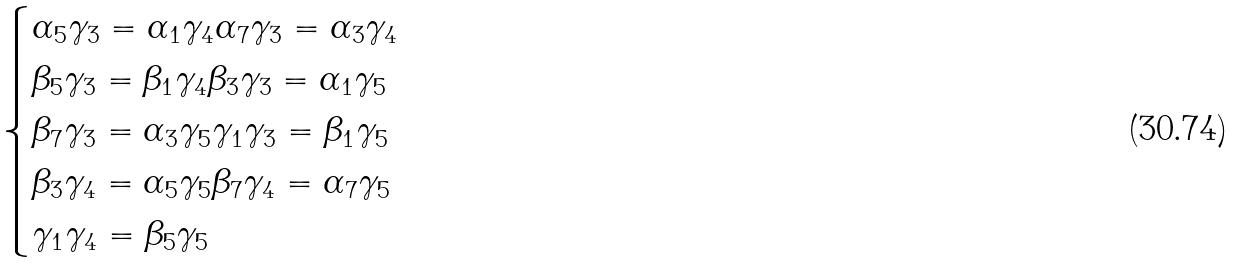Convert formula to latex. <formula><loc_0><loc_0><loc_500><loc_500>\begin{cases} \alpha _ { 5 } \gamma _ { 3 } = \alpha _ { 1 } \gamma _ { 4 } \alpha _ { 7 } \gamma _ { 3 } = \alpha _ { 3 } \gamma _ { 4 } \\ \beta _ { 5 } \gamma _ { 3 } = \beta _ { 1 } \gamma _ { 4 } \beta _ { 3 } \gamma _ { 3 } = \alpha _ { 1 } \gamma _ { 5 } \\ \beta _ { 7 } \gamma _ { 3 } = \alpha _ { 3 } \gamma _ { 5 } \gamma _ { 1 } \gamma _ { 3 } = \beta _ { 1 } \gamma _ { 5 } \\ \beta _ { 3 } \gamma _ { 4 } = \alpha _ { 5 } \gamma _ { 5 } \beta _ { 7 } \gamma _ { 4 } = \alpha _ { 7 } \gamma _ { 5 } \\ \gamma _ { 1 } \gamma _ { 4 } = \beta _ { 5 } \gamma _ { 5 } \end{cases}</formula> 